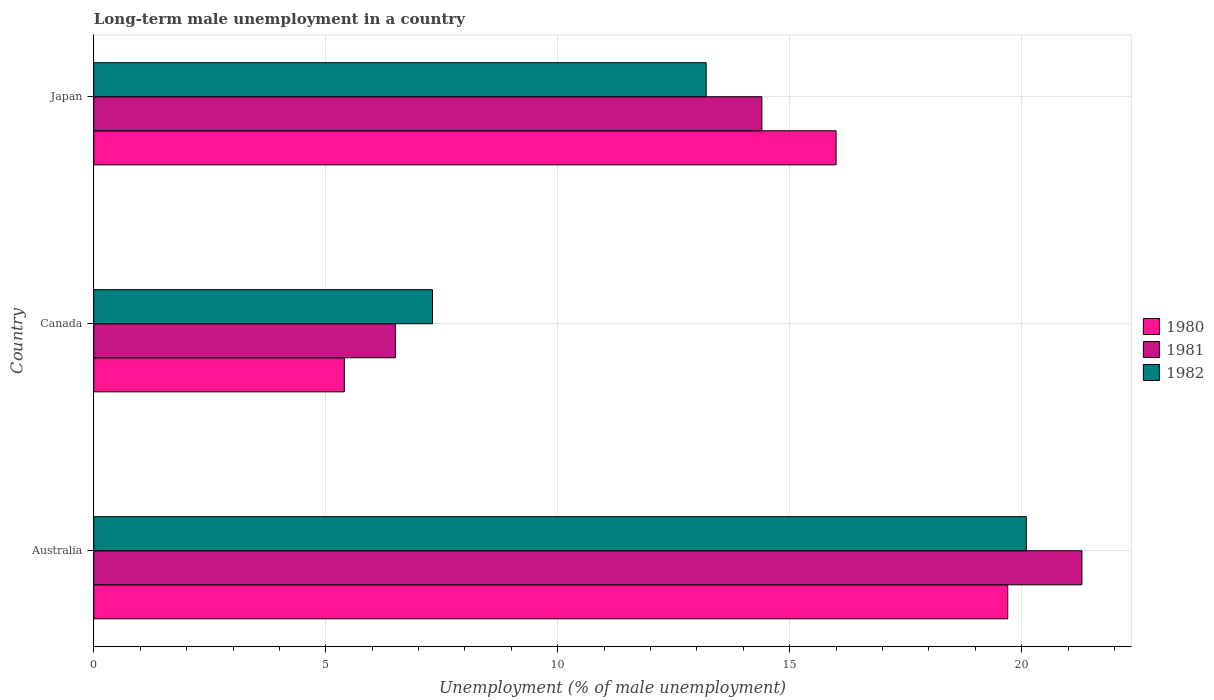How many groups of bars are there?
Your response must be concise. 3. Are the number of bars on each tick of the Y-axis equal?
Keep it short and to the point. Yes. How many bars are there on the 3rd tick from the top?
Keep it short and to the point. 3. How many bars are there on the 2nd tick from the bottom?
Give a very brief answer. 3. In how many cases, is the number of bars for a given country not equal to the number of legend labels?
Provide a short and direct response. 0. What is the percentage of long-term unemployed male population in 1982 in Japan?
Your answer should be very brief. 13.2. Across all countries, what is the maximum percentage of long-term unemployed male population in 1982?
Provide a short and direct response. 20.1. In which country was the percentage of long-term unemployed male population in 1981 minimum?
Keep it short and to the point. Canada. What is the total percentage of long-term unemployed male population in 1981 in the graph?
Provide a short and direct response. 42.2. What is the difference between the percentage of long-term unemployed male population in 1980 in Canada and that in Japan?
Provide a short and direct response. -10.6. What is the difference between the percentage of long-term unemployed male population in 1982 in Canada and the percentage of long-term unemployed male population in 1981 in Australia?
Make the answer very short. -14. What is the average percentage of long-term unemployed male population in 1980 per country?
Offer a terse response. 13.7. What is the difference between the percentage of long-term unemployed male population in 1980 and percentage of long-term unemployed male population in 1981 in Canada?
Offer a terse response. -1.1. What is the ratio of the percentage of long-term unemployed male population in 1980 in Australia to that in Canada?
Make the answer very short. 3.65. Is the difference between the percentage of long-term unemployed male population in 1980 in Australia and Japan greater than the difference between the percentage of long-term unemployed male population in 1981 in Australia and Japan?
Provide a succinct answer. No. What is the difference between the highest and the second highest percentage of long-term unemployed male population in 1981?
Your answer should be very brief. 6.9. What is the difference between the highest and the lowest percentage of long-term unemployed male population in 1982?
Make the answer very short. 12.8. Is the sum of the percentage of long-term unemployed male population in 1980 in Australia and Japan greater than the maximum percentage of long-term unemployed male population in 1981 across all countries?
Keep it short and to the point. Yes. What does the 3rd bar from the top in Japan represents?
Provide a succinct answer. 1980. What does the 3rd bar from the bottom in Canada represents?
Offer a terse response. 1982. Is it the case that in every country, the sum of the percentage of long-term unemployed male population in 1982 and percentage of long-term unemployed male population in 1980 is greater than the percentage of long-term unemployed male population in 1981?
Keep it short and to the point. Yes. How many bars are there?
Your response must be concise. 9. Are all the bars in the graph horizontal?
Your answer should be compact. Yes. What is the difference between two consecutive major ticks on the X-axis?
Offer a terse response. 5. Are the values on the major ticks of X-axis written in scientific E-notation?
Give a very brief answer. No. What is the title of the graph?
Provide a succinct answer. Long-term male unemployment in a country. What is the label or title of the X-axis?
Provide a short and direct response. Unemployment (% of male unemployment). What is the label or title of the Y-axis?
Your answer should be compact. Country. What is the Unemployment (% of male unemployment) in 1980 in Australia?
Provide a succinct answer. 19.7. What is the Unemployment (% of male unemployment) of 1981 in Australia?
Your answer should be compact. 21.3. What is the Unemployment (% of male unemployment) of 1982 in Australia?
Provide a succinct answer. 20.1. What is the Unemployment (% of male unemployment) of 1980 in Canada?
Ensure brevity in your answer.  5.4. What is the Unemployment (% of male unemployment) in 1981 in Canada?
Keep it short and to the point. 6.5. What is the Unemployment (% of male unemployment) of 1982 in Canada?
Keep it short and to the point. 7.3. What is the Unemployment (% of male unemployment) of 1981 in Japan?
Your response must be concise. 14.4. What is the Unemployment (% of male unemployment) of 1982 in Japan?
Offer a terse response. 13.2. Across all countries, what is the maximum Unemployment (% of male unemployment) in 1980?
Give a very brief answer. 19.7. Across all countries, what is the maximum Unemployment (% of male unemployment) in 1981?
Offer a very short reply. 21.3. Across all countries, what is the maximum Unemployment (% of male unemployment) in 1982?
Your answer should be very brief. 20.1. Across all countries, what is the minimum Unemployment (% of male unemployment) in 1980?
Offer a terse response. 5.4. Across all countries, what is the minimum Unemployment (% of male unemployment) in 1982?
Provide a short and direct response. 7.3. What is the total Unemployment (% of male unemployment) of 1980 in the graph?
Ensure brevity in your answer.  41.1. What is the total Unemployment (% of male unemployment) of 1981 in the graph?
Offer a terse response. 42.2. What is the total Unemployment (% of male unemployment) in 1982 in the graph?
Provide a short and direct response. 40.6. What is the difference between the Unemployment (% of male unemployment) of 1982 in Australia and that in Canada?
Ensure brevity in your answer.  12.8. What is the difference between the Unemployment (% of male unemployment) of 1981 in Australia and that in Japan?
Your response must be concise. 6.9. What is the difference between the Unemployment (% of male unemployment) of 1982 in Australia and that in Japan?
Your response must be concise. 6.9. What is the difference between the Unemployment (% of male unemployment) of 1980 in Canada and that in Japan?
Your response must be concise. -10.6. What is the difference between the Unemployment (% of male unemployment) in 1982 in Canada and that in Japan?
Provide a short and direct response. -5.9. What is the difference between the Unemployment (% of male unemployment) of 1981 in Australia and the Unemployment (% of male unemployment) of 1982 in Canada?
Ensure brevity in your answer.  14. What is the difference between the Unemployment (% of male unemployment) of 1981 in Australia and the Unemployment (% of male unemployment) of 1982 in Japan?
Offer a very short reply. 8.1. What is the difference between the Unemployment (% of male unemployment) of 1980 in Canada and the Unemployment (% of male unemployment) of 1982 in Japan?
Provide a succinct answer. -7.8. What is the difference between the Unemployment (% of male unemployment) of 1981 in Canada and the Unemployment (% of male unemployment) of 1982 in Japan?
Make the answer very short. -6.7. What is the average Unemployment (% of male unemployment) in 1980 per country?
Your answer should be compact. 13.7. What is the average Unemployment (% of male unemployment) in 1981 per country?
Your answer should be very brief. 14.07. What is the average Unemployment (% of male unemployment) in 1982 per country?
Ensure brevity in your answer.  13.53. What is the difference between the Unemployment (% of male unemployment) of 1980 and Unemployment (% of male unemployment) of 1982 in Canada?
Offer a very short reply. -1.9. What is the difference between the Unemployment (% of male unemployment) in 1981 and Unemployment (% of male unemployment) in 1982 in Canada?
Provide a succinct answer. -0.8. What is the difference between the Unemployment (% of male unemployment) of 1980 and Unemployment (% of male unemployment) of 1981 in Japan?
Make the answer very short. 1.6. What is the difference between the Unemployment (% of male unemployment) in 1980 and Unemployment (% of male unemployment) in 1982 in Japan?
Give a very brief answer. 2.8. What is the ratio of the Unemployment (% of male unemployment) of 1980 in Australia to that in Canada?
Provide a succinct answer. 3.65. What is the ratio of the Unemployment (% of male unemployment) in 1981 in Australia to that in Canada?
Your answer should be compact. 3.28. What is the ratio of the Unemployment (% of male unemployment) of 1982 in Australia to that in Canada?
Your answer should be compact. 2.75. What is the ratio of the Unemployment (% of male unemployment) of 1980 in Australia to that in Japan?
Ensure brevity in your answer.  1.23. What is the ratio of the Unemployment (% of male unemployment) of 1981 in Australia to that in Japan?
Provide a short and direct response. 1.48. What is the ratio of the Unemployment (% of male unemployment) of 1982 in Australia to that in Japan?
Provide a succinct answer. 1.52. What is the ratio of the Unemployment (% of male unemployment) of 1980 in Canada to that in Japan?
Your answer should be compact. 0.34. What is the ratio of the Unemployment (% of male unemployment) of 1981 in Canada to that in Japan?
Provide a short and direct response. 0.45. What is the ratio of the Unemployment (% of male unemployment) in 1982 in Canada to that in Japan?
Give a very brief answer. 0.55. What is the difference between the highest and the second highest Unemployment (% of male unemployment) in 1980?
Offer a very short reply. 3.7. What is the difference between the highest and the second highest Unemployment (% of male unemployment) of 1981?
Offer a terse response. 6.9. What is the difference between the highest and the lowest Unemployment (% of male unemployment) of 1980?
Provide a succinct answer. 14.3. 